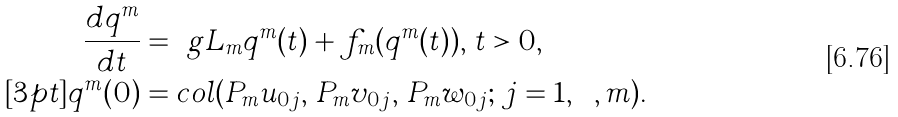<formula> <loc_0><loc_0><loc_500><loc_500>\frac { d q ^ { m } } { d t } & = \ g L _ { m } q ^ { m } ( t ) + f _ { m } ( q ^ { m } ( t ) ) , \, t > 0 , \\ [ 3 p t ] q ^ { m } ( 0 ) & = c o l ( P _ { m } u _ { 0 j } , \, P _ { m } v _ { 0 j } , \, P _ { m } w _ { 0 j } ; \, j = 1 , \cdots , m ) .</formula> 